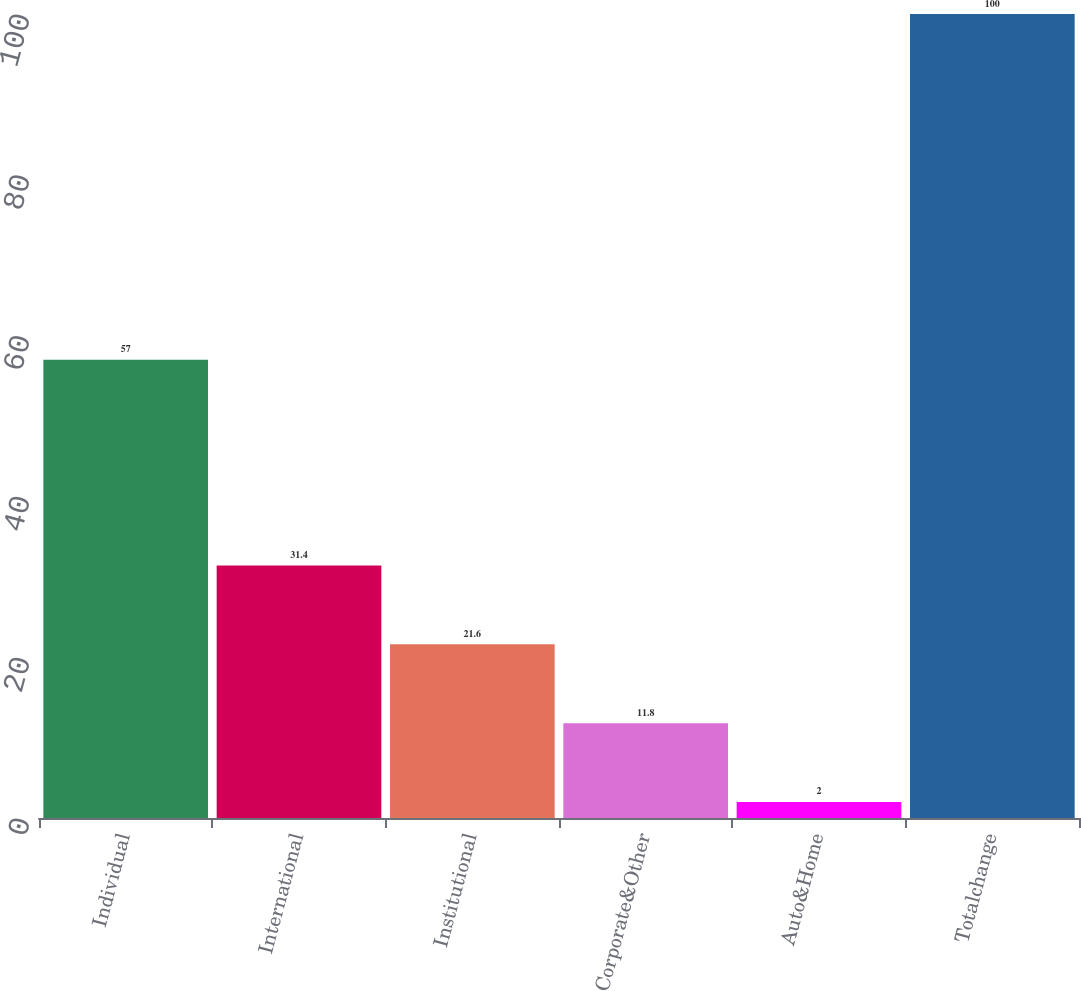Convert chart to OTSL. <chart><loc_0><loc_0><loc_500><loc_500><bar_chart><fcel>Individual<fcel>International<fcel>Institutional<fcel>Corporate&Other<fcel>Auto&Home<fcel>Totalchange<nl><fcel>57<fcel>31.4<fcel>21.6<fcel>11.8<fcel>2<fcel>100<nl></chart> 